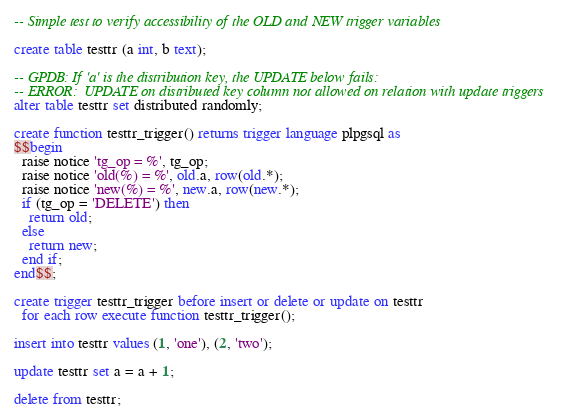<code> <loc_0><loc_0><loc_500><loc_500><_SQL_>-- Simple test to verify accessibility of the OLD and NEW trigger variables

create table testtr (a int, b text);

-- GPDB: If 'a' is the distribution key, the UPDATE below fails:
-- ERROR:  UPDATE on distributed key column not allowed on relation with update triggers
alter table testtr set distributed randomly;

create function testtr_trigger() returns trigger language plpgsql as
$$begin
  raise notice 'tg_op = %', tg_op;
  raise notice 'old(%) = %', old.a, row(old.*);
  raise notice 'new(%) = %', new.a, row(new.*);
  if (tg_op = 'DELETE') then
    return old;
  else
    return new;
  end if;
end$$;

create trigger testtr_trigger before insert or delete or update on testtr
  for each row execute function testtr_trigger();

insert into testtr values (1, 'one'), (2, 'two');

update testtr set a = a + 1;

delete from testtr;
</code> 